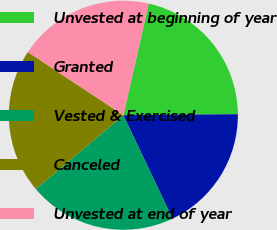<chart> <loc_0><loc_0><loc_500><loc_500><pie_chart><fcel>Unvested at beginning of year<fcel>Granted<fcel>Vested & Exercised<fcel>Canceled<fcel>Unvested at end of year<nl><fcel>21.3%<fcel>18.09%<fcel>20.9%<fcel>20.46%<fcel>19.25%<nl></chart> 